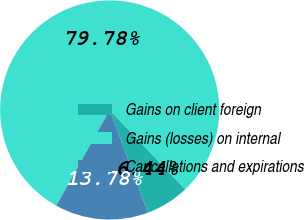Convert chart to OTSL. <chart><loc_0><loc_0><loc_500><loc_500><pie_chart><fcel>Gains on client foreign<fcel>Gains (losses) on internal<fcel>Cancellations and expirations<nl><fcel>6.44%<fcel>79.78%<fcel>13.78%<nl></chart> 